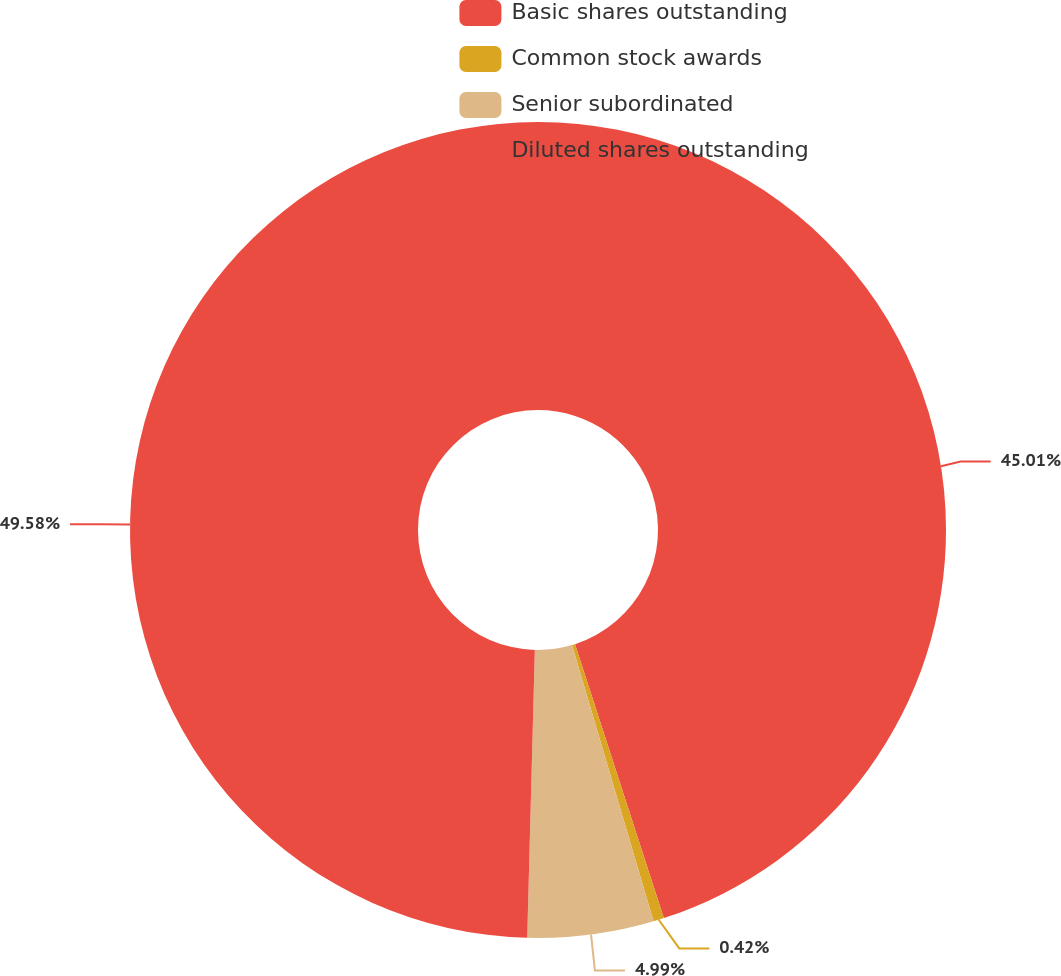Convert chart to OTSL. <chart><loc_0><loc_0><loc_500><loc_500><pie_chart><fcel>Basic shares outstanding<fcel>Common stock awards<fcel>Senior subordinated<fcel>Diluted shares outstanding<nl><fcel>45.01%<fcel>0.42%<fcel>4.99%<fcel>49.58%<nl></chart> 